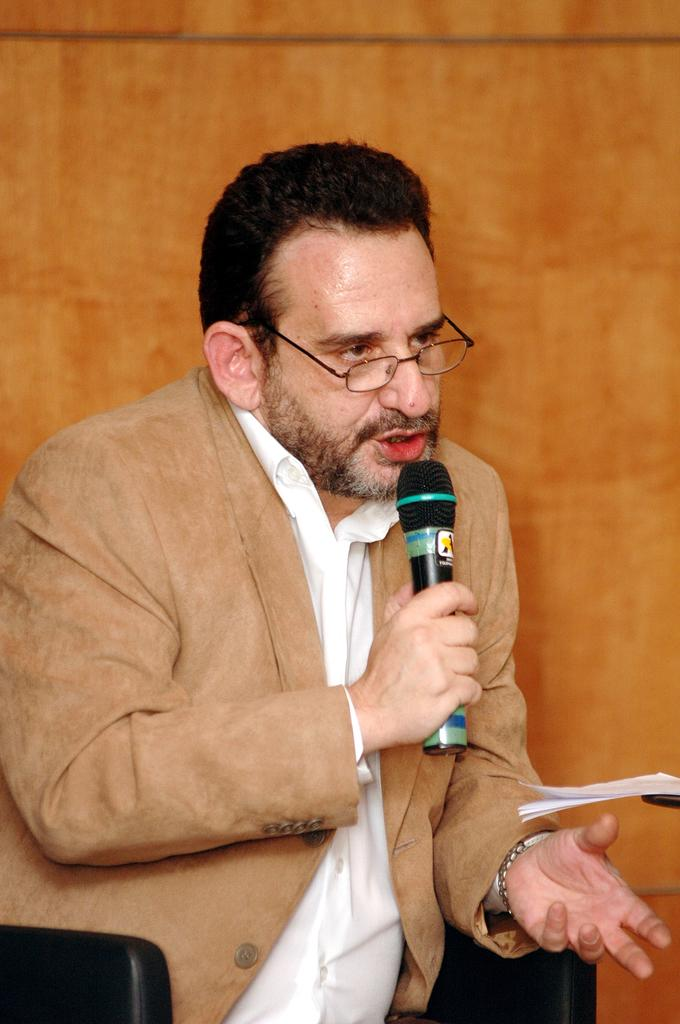Who is the main subject in the image? There is a man in the image. What is the man wearing on his face? The man is wearing spectacles. What is the man holding in his right hand? The man is holding a microphone in his right hand. What is the color of the background in the image? The background color is orange. What type of clothing is the man wearing? The man is wearing a suit. What day of the week is depicted in the image? The image does not depict a specific day of the week; it is a still image of a man holding a microphone. What type of gardening tool is the man using in the image? There is no gardening tool, such as a rake, present in the image. 